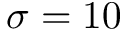<formula> <loc_0><loc_0><loc_500><loc_500>\sigma = 1 0</formula> 